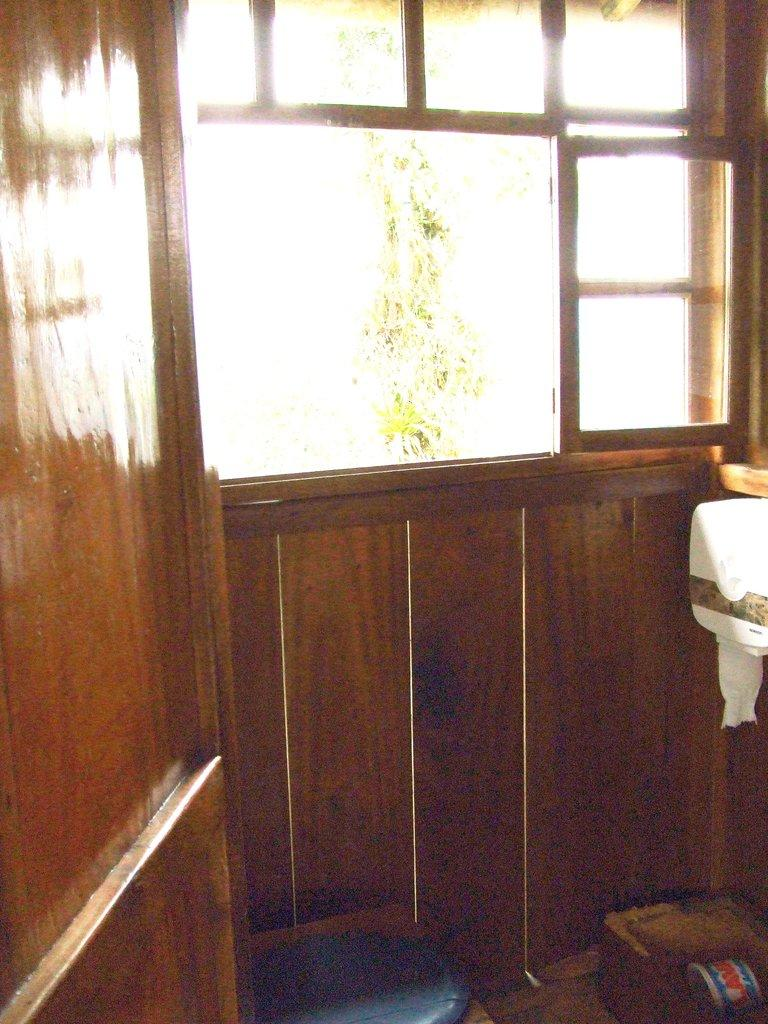What type of structure can be seen in the image? There is a wall in the image. Is there any opening in the wall? Yes, there is a window in the image. What is placed near the window? There is a tissue box in the image. What can be seen on the floor in the image? There are objects on the floor in the image. What type of soup is being served in the image? There is no soup present in the image. Can you tell me how many beads are on the floor in the image? There is no mention of beads in the image, so it is not possible to determine their quantity. 